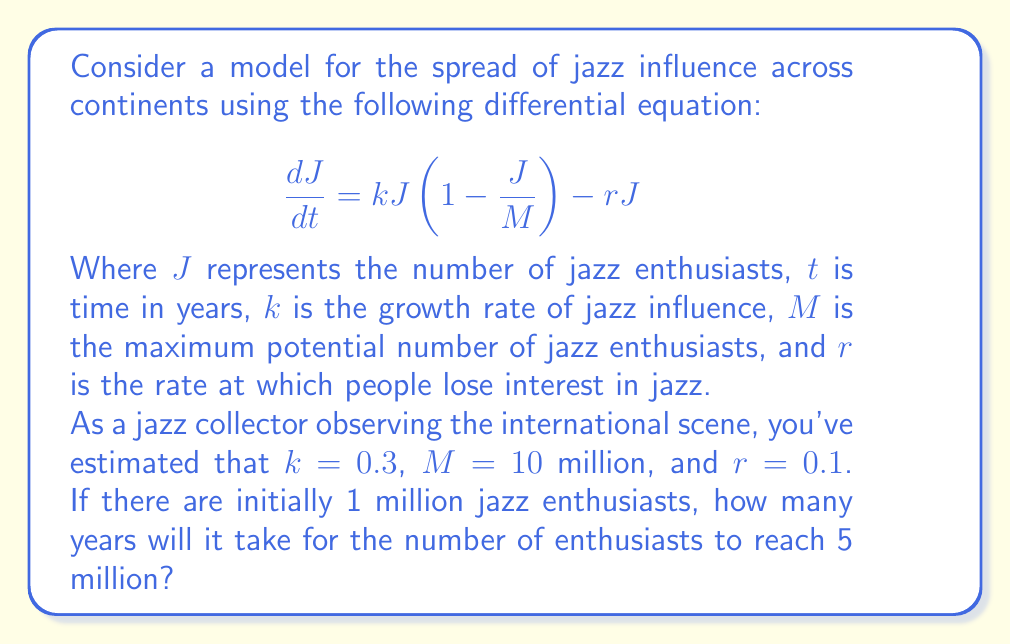Solve this math problem. Let's approach this step-by-step:

1) First, we need to solve the differential equation. The equation is in the form of a logistic growth model with a decay term.

2) At equilibrium, $\frac{dJ}{dt} = 0$. So:

   $$0 = kJ(1-\frac{J}{M}) - rJ$$

3) Solving this, we get two equilibrium points: $J=0$ and $J=M(1-\frac{r}{k})$

4) The non-zero equilibrium point is:

   $$J_{eq} = 10(1-\frac{0.1}{0.3}) = 6.67 \text{ million}$$

5) The general solution to this differential equation is:

   $$J(t) = \frac{J_{eq}}{1 + (\frac{J_{eq}}{J_0} - 1)e^{-(k-r)t}}$$

   Where $J_0$ is the initial number of enthusiasts.

6) Substituting our values:

   $$J(t) = \frac{6.67}{1 + (\frac{6.67}{1} - 1)e^{-0.2t}}$$

7) We want to find $t$ when $J(t) = 5$ million. So:

   $$5 = \frac{6.67}{1 + 5.67e^{-0.2t}}$$

8) Solving for $t$:

   $$1 + 5.67e^{-0.2t} = \frac{6.67}{5}$$
   $$5.67e^{-0.2t} = \frac{6.67}{5} - 1 = 0.334$$
   $$e^{-0.2t} = \frac{0.334}{5.67} = 0.0589$$
   $$-0.2t = \ln(0.0589)$$
   $$t = \frac{-\ln(0.0589)}{0.2} \approx 14.2$$

Therefore, it will take approximately 14.2 years for the number of jazz enthusiasts to reach 5 million.
Answer: 14.2 years 